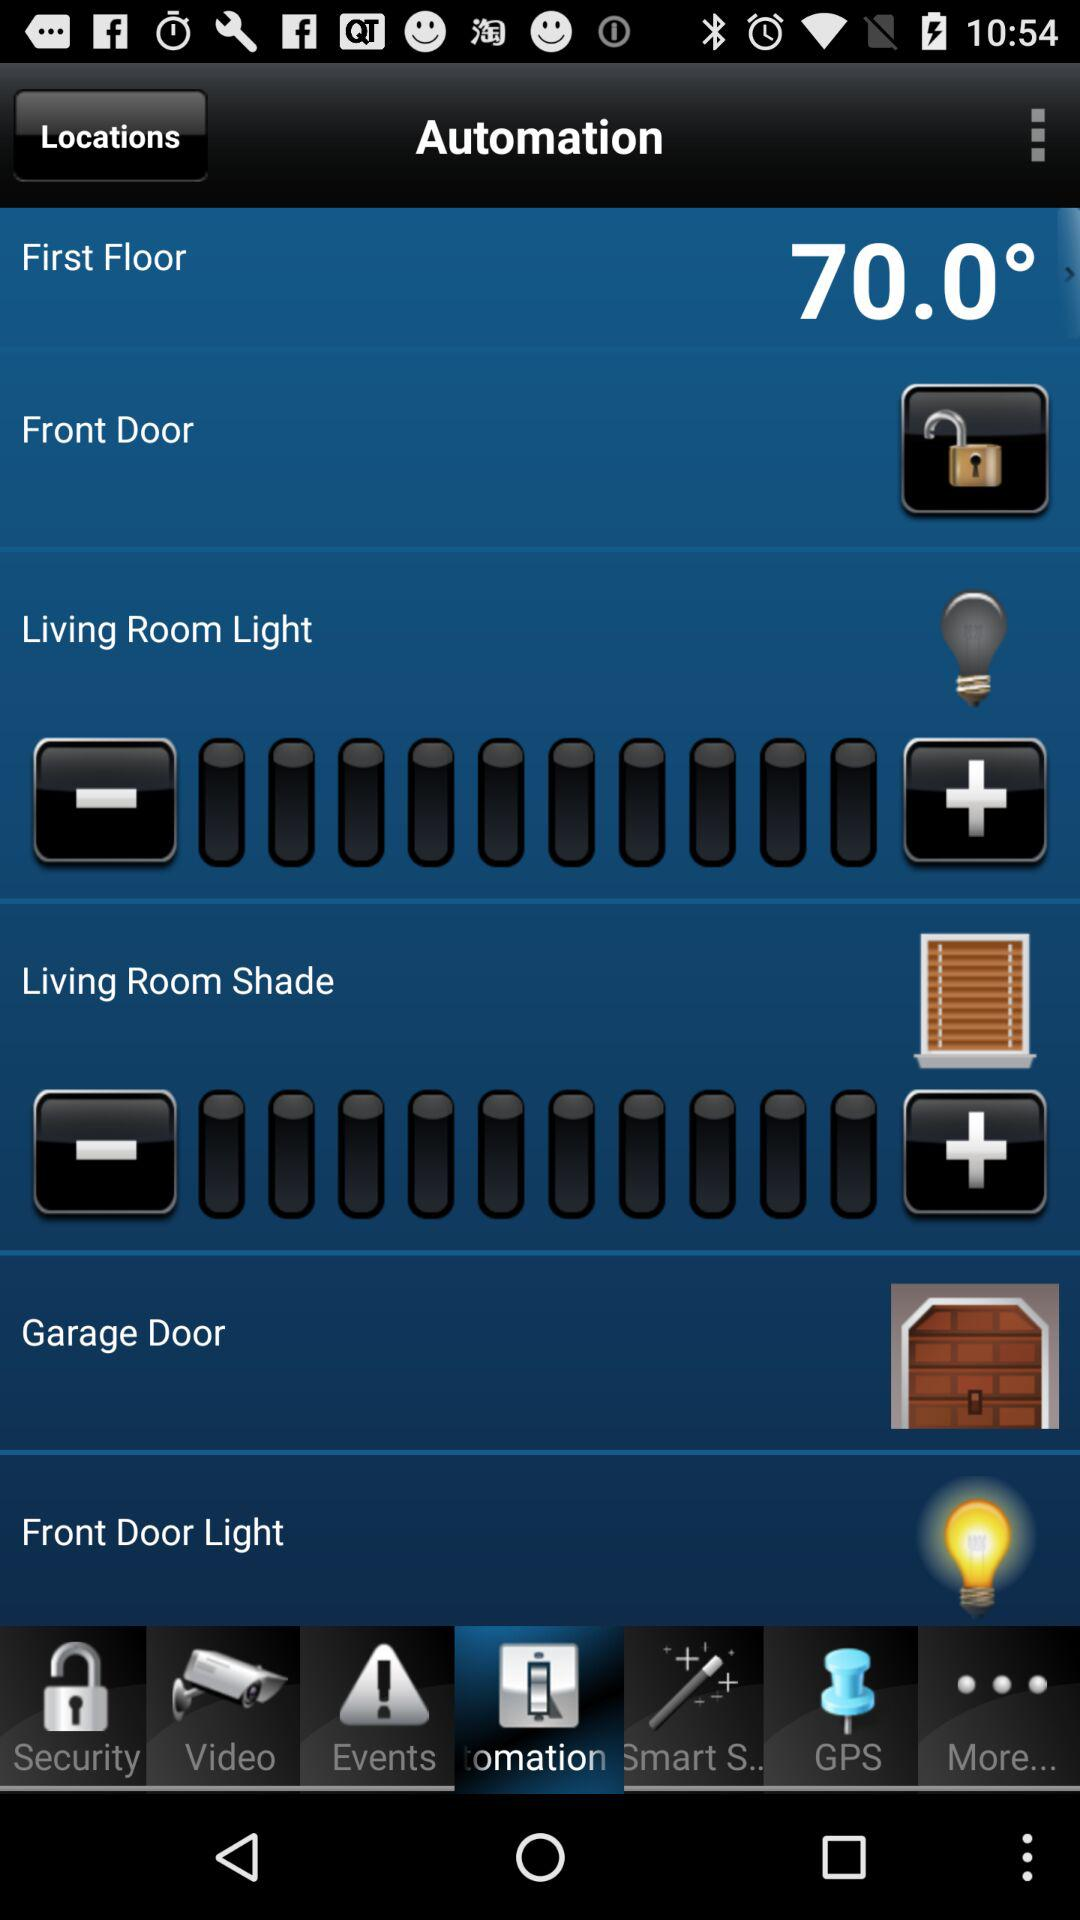Which door light is turned on? The door light that is turned on is for the front door. 